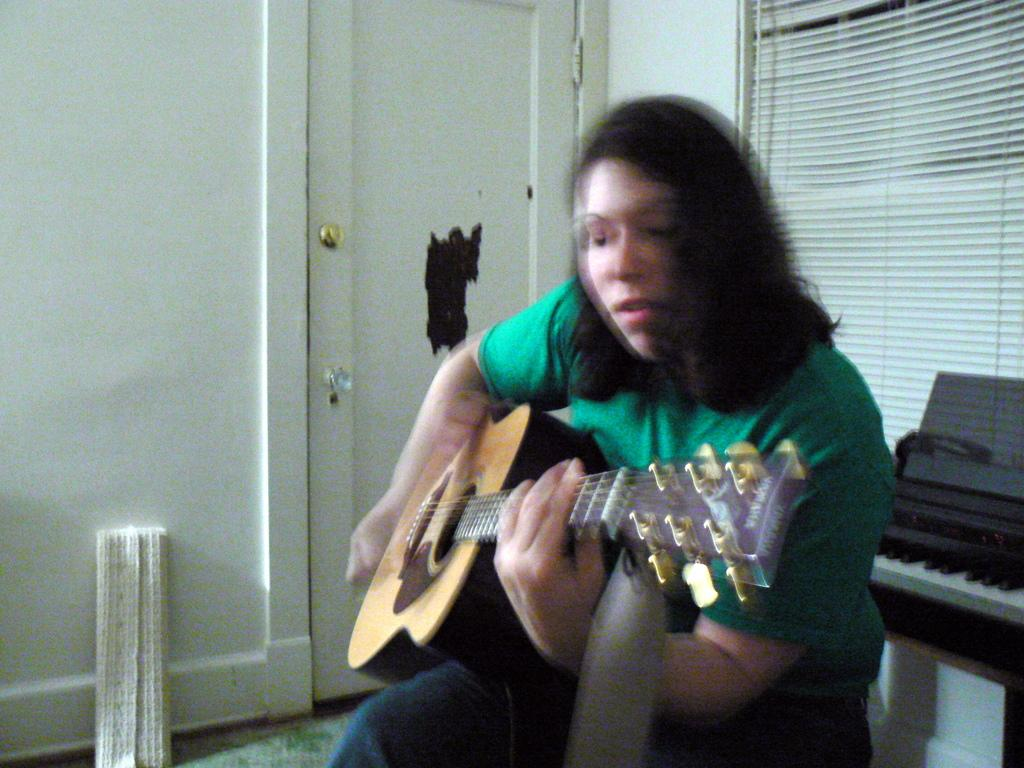Who is present in the image? There is a woman in the image. What is the woman wearing? The woman is wearing a green t-shirt. What is the woman holding in the image? The woman is holding a guitar. What is the woman doing with the guitar? The woman is playing the guitar. What can be seen in the background of the image? There is a keyboard and a curtain in the background. What other objects are present in the image? There is a cupboard and a mat near the cupboard. What type of locket can be seen hanging from the guitar in the image? There is no locket present on the guitar in the image. Can you see a giraffe in the background of the image? There is no giraffe present in the image. 